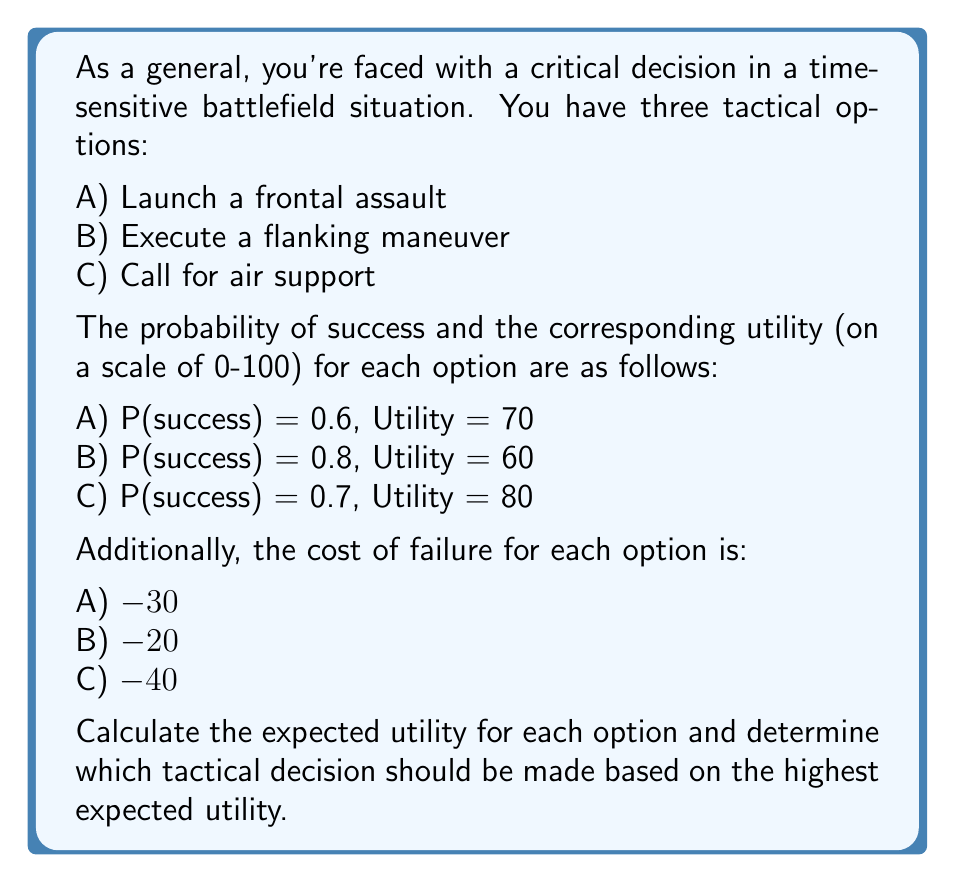Provide a solution to this math problem. To solve this problem, we need to calculate the expected utility for each option using the formula:

$$ E(U) = P(success) \times U(success) + P(failure) \times U(failure) $$

Where:
$E(U)$ is the expected utility
$P(success)$ is the probability of success
$U(success)$ is the utility of success
$P(failure) = 1 - P(success)$
$U(failure)$ is the utility (cost) of failure

Let's calculate for each option:

Option A: Frontal Assault
$$ E(U_A) = 0.6 \times 70 + (1 - 0.6) \times (-30) $$
$$ E(U_A) = 42 + (-12) = 30 $$

Option B: Flanking Maneuver
$$ E(U_B) = 0.8 \times 60 + (1 - 0.8) \times (-20) $$
$$ E(U_B) = 48 + (-4) = 44 $$

Option C: Air Support
$$ E(U_C) = 0.7 \times 80 + (1 - 0.7) \times (-40) $$
$$ E(U_C) = 56 + (-12) = 44 $$

Comparing the expected utilities:
$E(U_A) = 30$
$E(U_B) = 44$
$E(U_C) = 44$

We can see that options B and C have the highest expected utility of 44.
Answer: The highest expected utility is 44, achieved by both Option B (Flanking Maneuver) and Option C (Air Support). As a seasoned general known for calm decision-making, you should choose either the flanking maneuver or call for air support, as both offer the same optimal expected utility in this time-sensitive situation. 